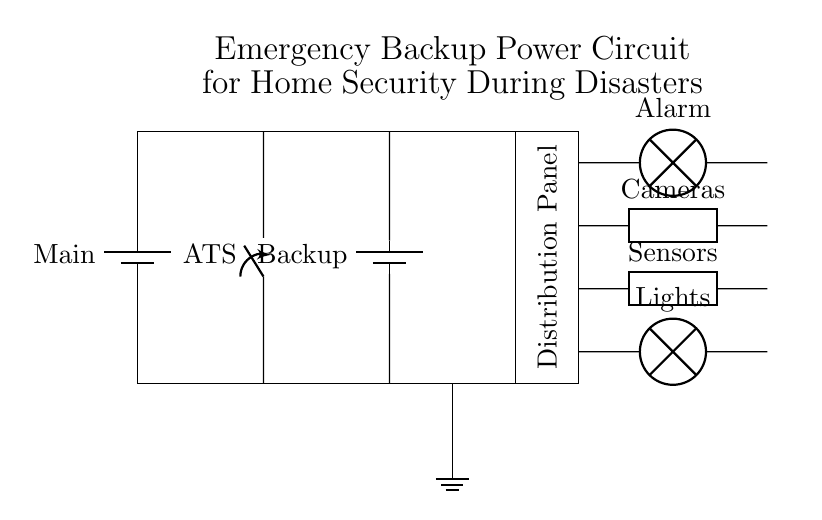What is the main power source in this circuit? The main power source is a battery labeled "Main," providing the primary voltage to the circuit.
Answer: Main What does ATS stand for in this circuit? ATS stands for "Automatic Transfer Switch," which is used to switch between the main power source and the backup power source.
Answer: Automatic Transfer Switch How many types of security devices are connected to the distribution panel? There are four types of security devices: Alarm, Cameras, Sensors, and Lights, each connected for home security.
Answer: Four Which component provides backup power? The backup power is provided by a battery labeled "Backup," which ensures that the security devices remain operational during power outage events.
Answer: Backup What is the role of the distribution panel in this circuit? The distribution panel distributes the power from both the main source and the backup source to the connected security devices, ensuring they can operate under either condition.
Answer: Distributes power Which security device is connected to the highest position in the circuit layout? The security device in the highest position is the "Alarm," indicating that it may have priority in power supply or signaling.
Answer: Alarm 